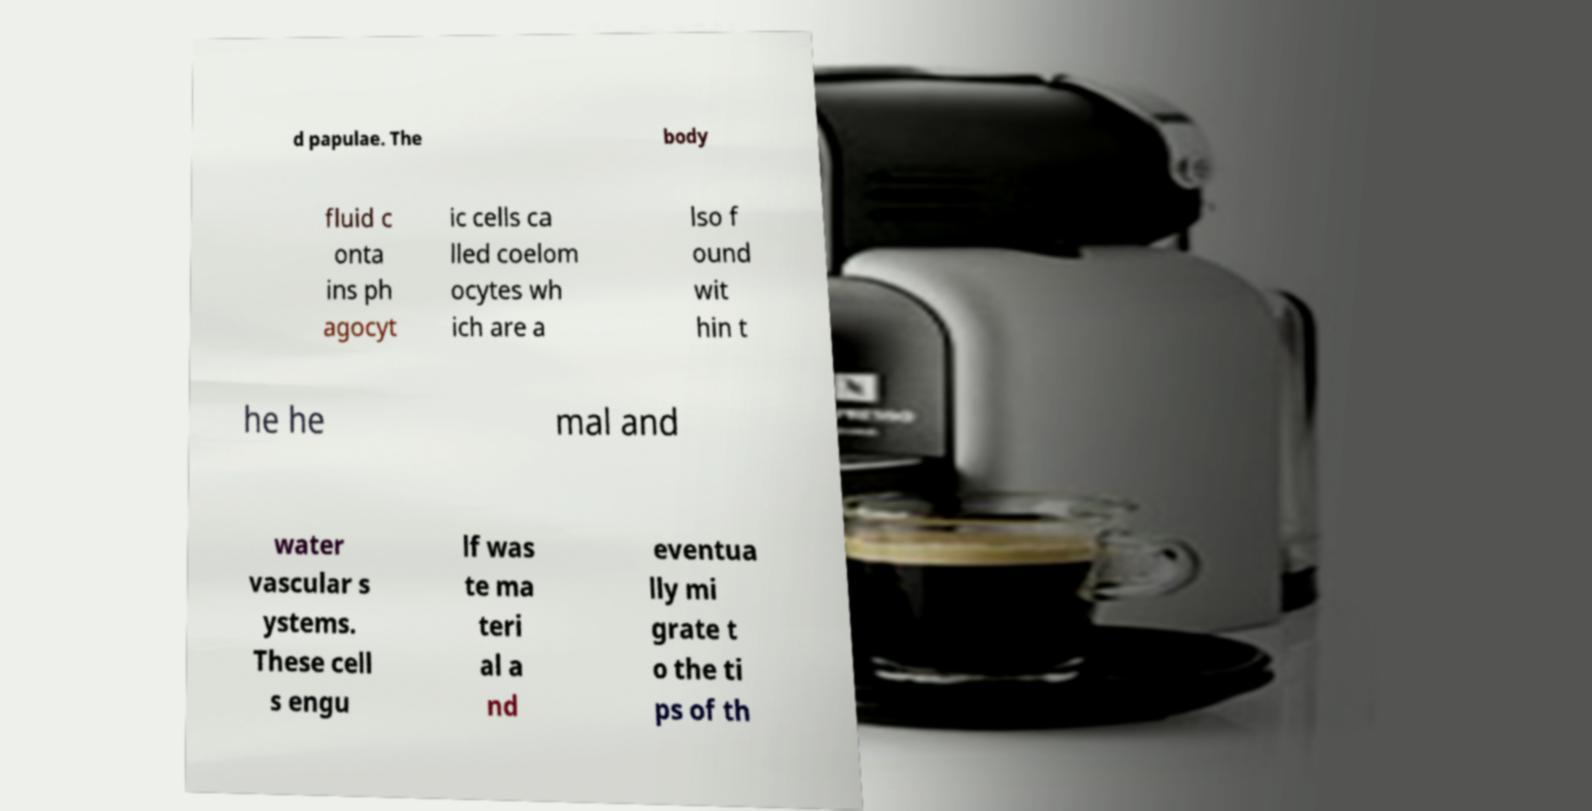Can you accurately transcribe the text from the provided image for me? d papulae. The body fluid c onta ins ph agocyt ic cells ca lled coelom ocytes wh ich are a lso f ound wit hin t he he mal and water vascular s ystems. These cell s engu lf was te ma teri al a nd eventua lly mi grate t o the ti ps of th 